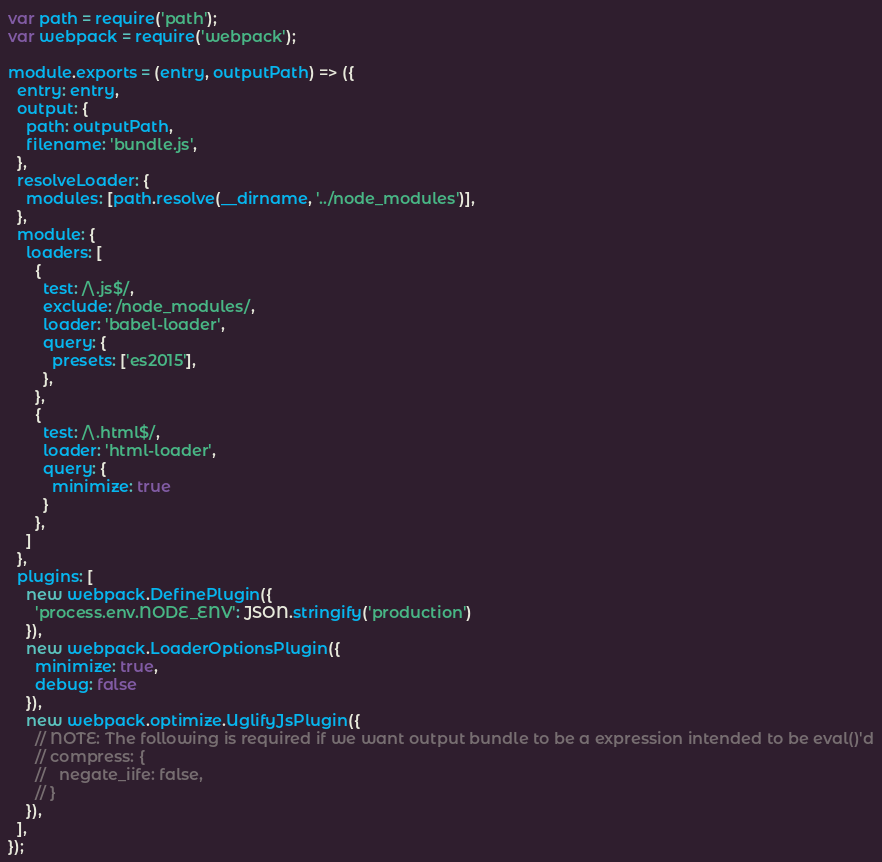Convert code to text. <code><loc_0><loc_0><loc_500><loc_500><_JavaScript_>var path = require('path');
var webpack = require('webpack');

module.exports = (entry, outputPath) => ({
  entry: entry,
  output: {
    path: outputPath,
    filename: 'bundle.js',
  },
  resolveLoader: {
    modules: [path.resolve(__dirname, '../node_modules')],
  },
  module: {
    loaders: [
      {
        test: /\.js$/,
        exclude: /node_modules/,
        loader: 'babel-loader',
        query: {
          presets: ['es2015'],
        },
      },
      {
        test: /\.html$/,
        loader: 'html-loader',
        query: {
          minimize: true
        }
      },
    ]
  },
  plugins: [
    new webpack.DefinePlugin({
      'process.env.NODE_ENV': JSON.stringify('production')
    }),
    new webpack.LoaderOptionsPlugin({
      minimize: true,
      debug: false
    }),
    new webpack.optimize.UglifyJsPlugin({
      // NOTE: The following is required if we want output bundle to be a expression intended to be eval()'d
      // compress: {
      //   negate_iife: false,
      // }
    }),
  ],
});
</code> 